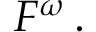<formula> <loc_0><loc_0><loc_500><loc_500>F ^ { \omega } \, .</formula> 